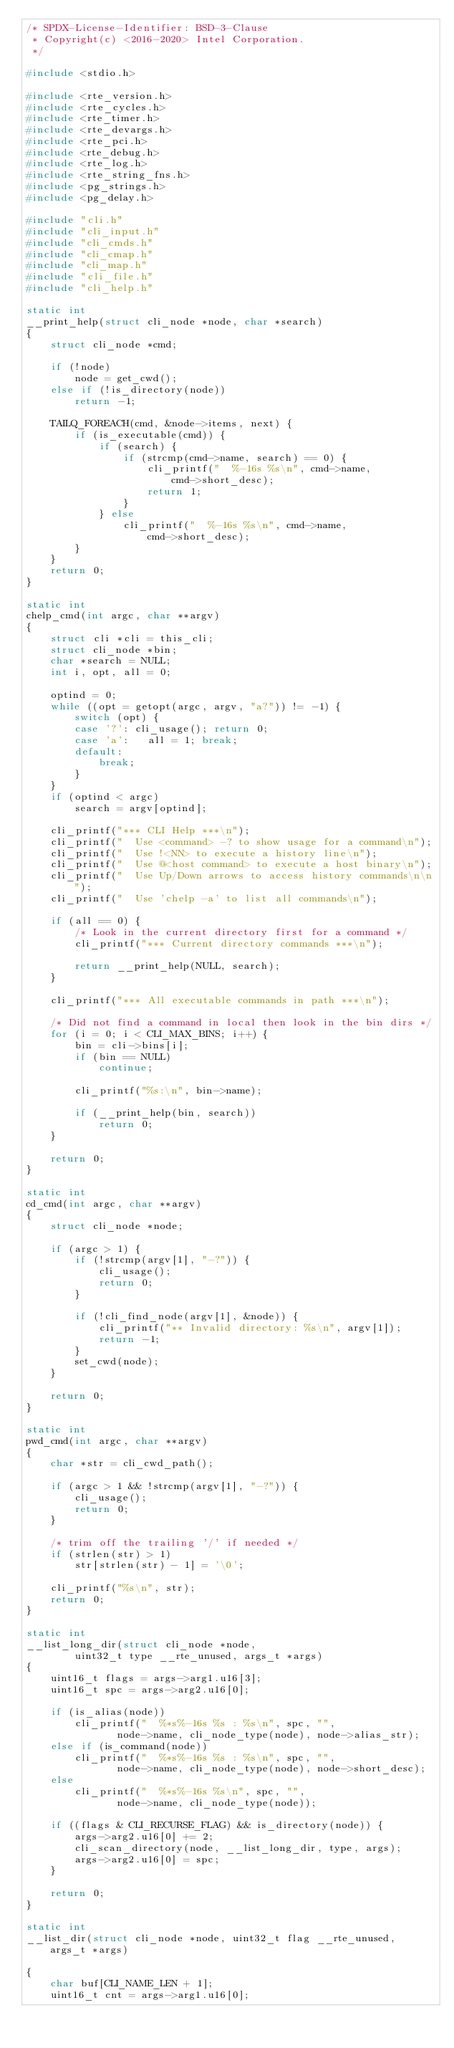Convert code to text. <code><loc_0><loc_0><loc_500><loc_500><_C_>/* SPDX-License-Identifier: BSD-3-Clause
 * Copyright(c) <2016-2020> Intel Corporation.
 */

#include <stdio.h>

#include <rte_version.h>
#include <rte_cycles.h>
#include <rte_timer.h>
#include <rte_devargs.h>
#include <rte_pci.h>
#include <rte_debug.h>
#include <rte_log.h>
#include <rte_string_fns.h>
#include <pg_strings.h>
#include <pg_delay.h>

#include "cli.h"
#include "cli_input.h"
#include "cli_cmds.h"
#include "cli_cmap.h"
#include "cli_map.h"
#include "cli_file.h"
#include "cli_help.h"

static int
__print_help(struct cli_node *node, char *search)
{
	struct cli_node *cmd;

	if (!node)
		node = get_cwd();
	else if (!is_directory(node))
		return -1;

	TAILQ_FOREACH(cmd, &node->items, next) {
		if (is_executable(cmd)) {
			if (search) {
				if (strcmp(cmd->name, search) == 0) {
					cli_printf("  %-16s %s\n", cmd->name,
						cmd->short_desc);
					return 1;
				}
			} else
				cli_printf("  %-16s %s\n", cmd->name,
					cmd->short_desc);
		}
	}
	return 0;
}

static int
chelp_cmd(int argc, char **argv)
{
	struct cli *cli = this_cli;
	struct cli_node *bin;
	char *search = NULL;
	int i, opt, all = 0;

	optind = 0;
	while ((opt = getopt(argc, argv, "a?")) != -1) {
		switch (opt) {
		case '?': cli_usage(); return 0;
		case 'a':   all = 1; break;
		default:
			break;
		}
	}
	if (optind < argc)
		search = argv[optind];

	cli_printf("*** CLI Help ***\n");
	cli_printf("  Use <command> -? to show usage for a command\n");
	cli_printf("  Use !<NN> to execute a history line\n");
	cli_printf("  Use @<host command> to execute a host binary\n");
	cli_printf("  Use Up/Down arrows to access history commands\n\n");
	cli_printf("  Use 'chelp -a' to list all commands\n");

	if (all == 0) {
		/* Look in the current directory first for a command */
		cli_printf("*** Current directory commands ***\n");

		return __print_help(NULL, search);
	}

	cli_printf("*** All executable commands in path ***\n");

	/* Did not find a command in local then look in the bin dirs */
	for (i = 0; i < CLI_MAX_BINS; i++) {
		bin = cli->bins[i];
		if (bin == NULL)
			continue;

		cli_printf("%s:\n", bin->name);

		if (__print_help(bin, search))
			return 0;
	}

	return 0;
}

static int
cd_cmd(int argc, char **argv)
{
	struct cli_node *node;

	if (argc > 1) {
		if (!strcmp(argv[1], "-?")) {
			cli_usage();
			return 0;
		}

		if (!cli_find_node(argv[1], &node)) {
			cli_printf("** Invalid directory: %s\n", argv[1]);
			return -1;
		}
		set_cwd(node);
	}

	return 0;
}

static int
pwd_cmd(int argc, char **argv)
{
	char *str = cli_cwd_path();

	if (argc > 1 && !strcmp(argv[1], "-?")) {
		cli_usage();
		return 0;
	}

	/* trim off the trailing '/' if needed */
	if (strlen(str) > 1)
		str[strlen(str) - 1] = '\0';

	cli_printf("%s\n", str);
	return 0;
}

static int
__list_long_dir(struct cli_node *node,
		uint32_t type __rte_unused, args_t *args)
{
	uint16_t flags = args->arg1.u16[3];
	uint16_t spc = args->arg2.u16[0];

	if (is_alias(node))
		cli_printf("  %*s%-16s %s : %s\n", spc, "",
			   node->name, cli_node_type(node), node->alias_str);
	else if (is_command(node))
		cli_printf("  %*s%-16s %s : %s\n", spc, "",
			   node->name, cli_node_type(node), node->short_desc);
	else
		cli_printf("  %*s%-16s %s\n", spc, "",
			   node->name, cli_node_type(node));

	if ((flags & CLI_RECURSE_FLAG) && is_directory(node)) {
		args->arg2.u16[0] += 2;
		cli_scan_directory(node, __list_long_dir, type, args);
		args->arg2.u16[0] = spc;
	}

	return 0;
}

static int
__list_dir(struct cli_node *node, uint32_t flag __rte_unused, args_t *args)

{
	char buf[CLI_NAME_LEN + 1];
	uint16_t cnt = args->arg1.u16[0];</code> 